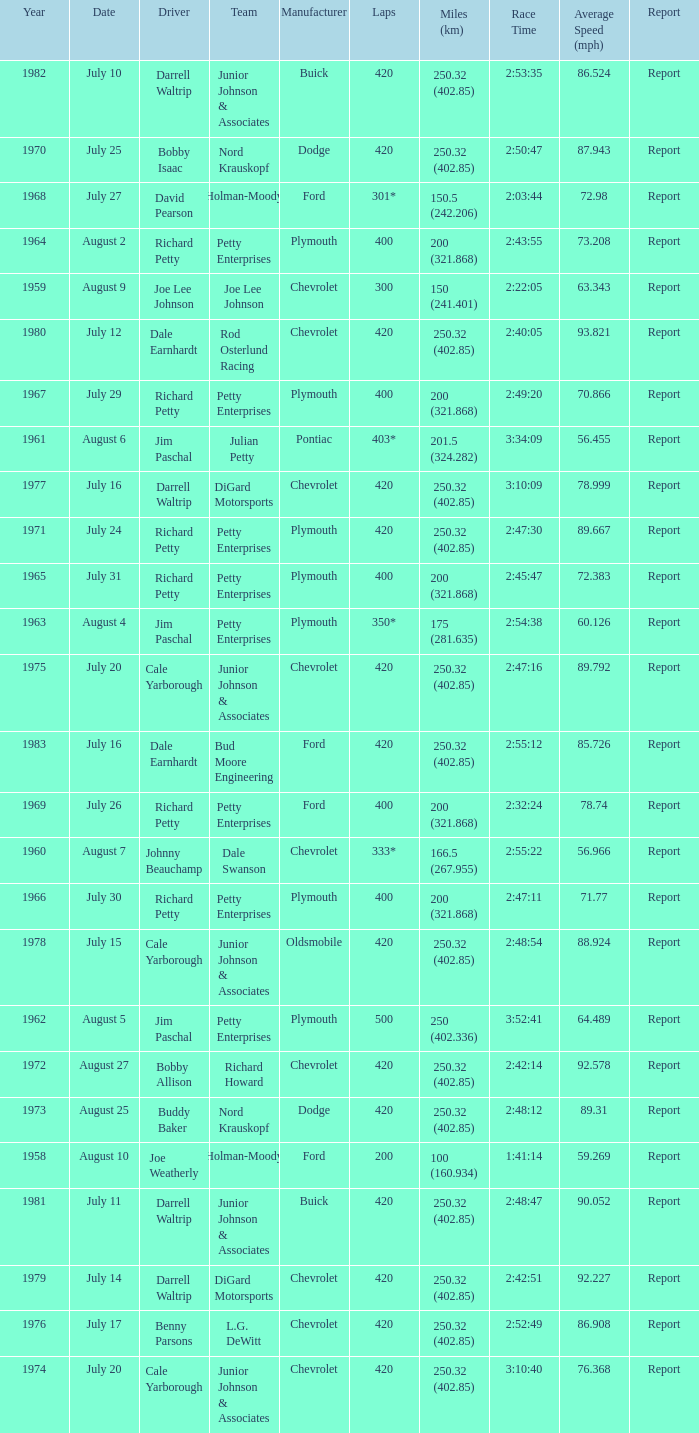How many races did Cale Yarborough win at an average speed of 88.924 mph? 1.0. 